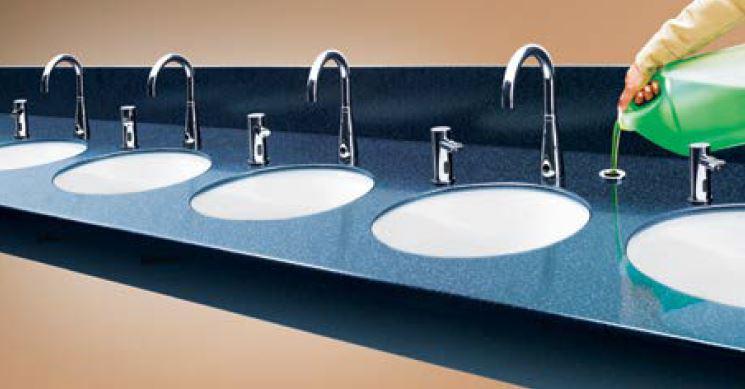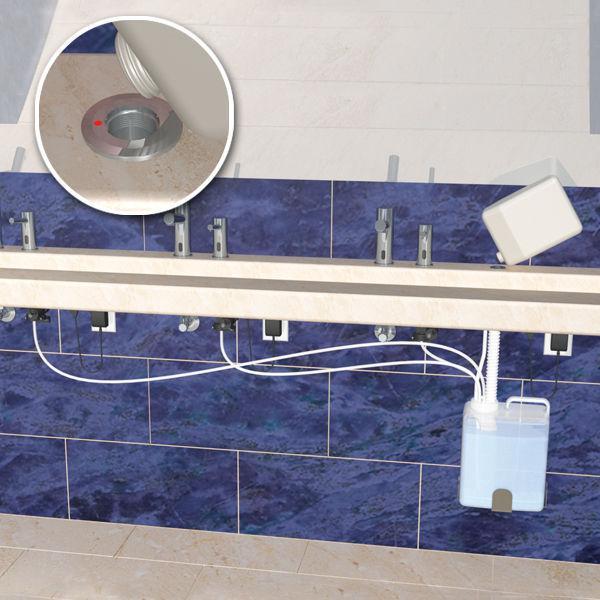The first image is the image on the left, the second image is the image on the right. For the images shown, is this caption "there is exactly one curved faucet in the image on the left" true? Answer yes or no. No. The first image is the image on the left, the second image is the image on the right. Given the left and right images, does the statement "Right image includes one rounded sink with squirt-type dispenser nearby." hold true? Answer yes or no. No. 